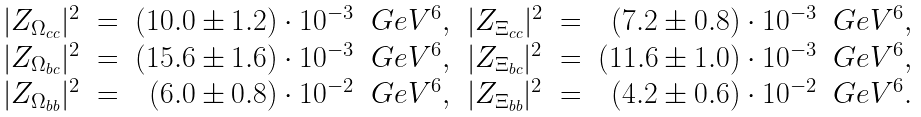Convert formula to latex. <formula><loc_0><loc_0><loc_500><loc_500>\begin{array} { l c r r l c r r } { { | Z _ { \Omega _ { c c } } | ^ { 2 } } } & { = } & { { ( 1 0 . 0 \pm 1 . 2 ) \cdot 1 0 ^ { - 3 } } } & { { G e V ^ { 6 } , } } & { { | Z _ { \Xi _ { c c } } | ^ { 2 } } } & { = } & { { ( 7 . 2 \pm 0 . 8 ) \cdot 1 0 ^ { - 3 } } } & { { G e V ^ { 6 } , } } \\ { { | Z _ { \Omega _ { b c } } | ^ { 2 } } } & { = } & { { ( 1 5 . 6 \pm 1 . 6 ) \cdot 1 0 ^ { - 3 } } } & { { G e V ^ { 6 } , } } & { { | Z _ { \Xi _ { b c } } | ^ { 2 } } } & { = } & { { ( 1 1 . 6 \pm 1 . 0 ) \cdot 1 0 ^ { - 3 } } } & { { G e V ^ { 6 } , } } \\ { { | Z _ { \Omega _ { b b } } | ^ { 2 } } } & { = } & { { ( 6 . 0 \pm 0 . 8 ) \cdot 1 0 ^ { - 2 } } } & { { G e V ^ { 6 } , } } & { { | Z _ { \Xi _ { b b } } | ^ { 2 } } } & { = } & { { ( 4 . 2 \pm 0 . 6 ) \cdot 1 0 ^ { - 2 } } } & { { G e V ^ { 6 } . } } \end{array}</formula> 